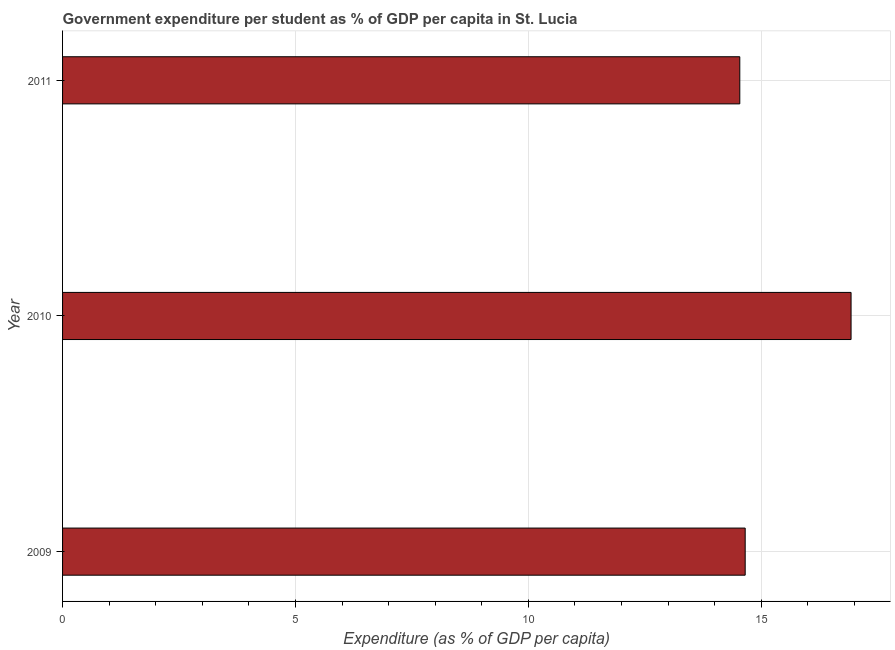Does the graph contain any zero values?
Offer a terse response. No. Does the graph contain grids?
Your answer should be very brief. Yes. What is the title of the graph?
Keep it short and to the point. Government expenditure per student as % of GDP per capita in St. Lucia. What is the label or title of the X-axis?
Offer a terse response. Expenditure (as % of GDP per capita). What is the label or title of the Y-axis?
Provide a short and direct response. Year. What is the government expenditure per student in 2009?
Make the answer very short. 14.66. Across all years, what is the maximum government expenditure per student?
Make the answer very short. 16.93. Across all years, what is the minimum government expenditure per student?
Give a very brief answer. 14.54. In which year was the government expenditure per student minimum?
Ensure brevity in your answer.  2011. What is the sum of the government expenditure per student?
Your response must be concise. 46.13. What is the difference between the government expenditure per student in 2009 and 2010?
Your answer should be compact. -2.27. What is the average government expenditure per student per year?
Offer a terse response. 15.38. What is the median government expenditure per student?
Keep it short and to the point. 14.66. In how many years, is the government expenditure per student greater than 1 %?
Keep it short and to the point. 3. Do a majority of the years between 2011 and 2010 (inclusive) have government expenditure per student greater than 15 %?
Ensure brevity in your answer.  No. What is the ratio of the government expenditure per student in 2010 to that in 2011?
Keep it short and to the point. 1.16. Is the difference between the government expenditure per student in 2010 and 2011 greater than the difference between any two years?
Give a very brief answer. Yes. What is the difference between the highest and the second highest government expenditure per student?
Provide a succinct answer. 2.27. What is the difference between the highest and the lowest government expenditure per student?
Provide a succinct answer. 2.39. How many bars are there?
Give a very brief answer. 3. Are the values on the major ticks of X-axis written in scientific E-notation?
Make the answer very short. No. What is the Expenditure (as % of GDP per capita) in 2009?
Your response must be concise. 14.66. What is the Expenditure (as % of GDP per capita) in 2010?
Provide a short and direct response. 16.93. What is the Expenditure (as % of GDP per capita) of 2011?
Make the answer very short. 14.54. What is the difference between the Expenditure (as % of GDP per capita) in 2009 and 2010?
Make the answer very short. -2.27. What is the difference between the Expenditure (as % of GDP per capita) in 2009 and 2011?
Your answer should be very brief. 0.12. What is the difference between the Expenditure (as % of GDP per capita) in 2010 and 2011?
Your answer should be compact. 2.39. What is the ratio of the Expenditure (as % of GDP per capita) in 2009 to that in 2010?
Keep it short and to the point. 0.87. What is the ratio of the Expenditure (as % of GDP per capita) in 2010 to that in 2011?
Give a very brief answer. 1.16. 